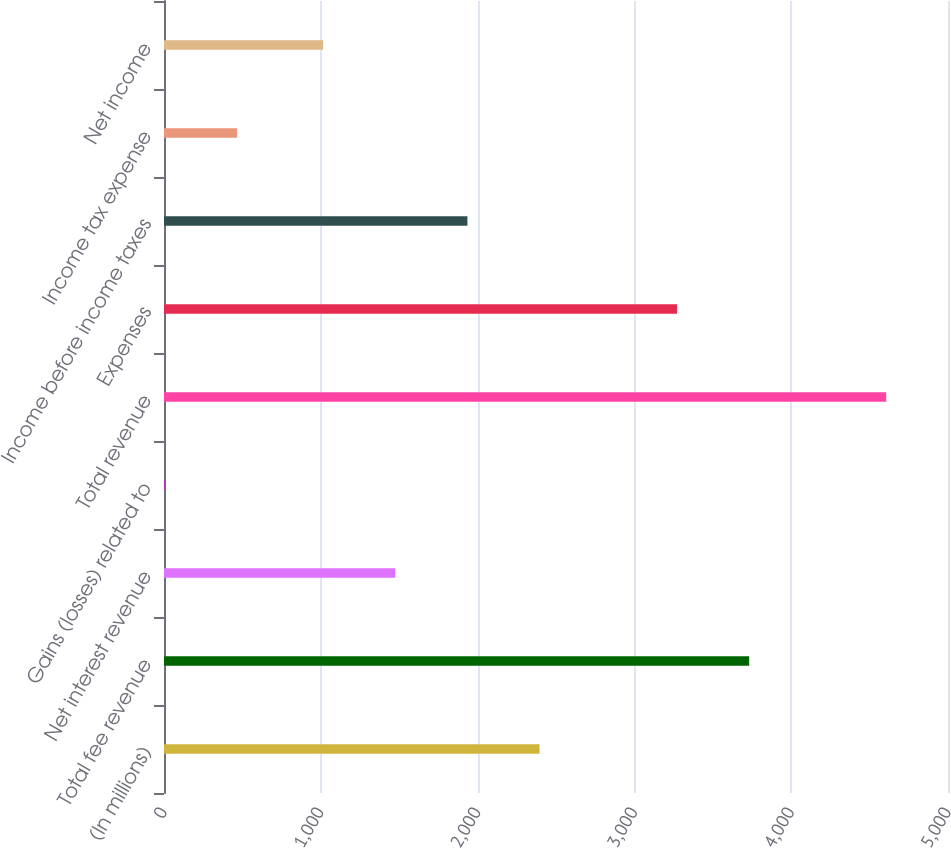Convert chart to OTSL. <chart><loc_0><loc_0><loc_500><loc_500><bar_chart><fcel>(In millions)<fcel>Total fee revenue<fcel>Net interest revenue<fcel>Gains (losses) related to<fcel>Total revenue<fcel>Expenses<fcel>Income before income taxes<fcel>Income tax expense<fcel>Net income<nl><fcel>2395<fcel>3732<fcel>1475<fcel>6<fcel>4606<fcel>3272<fcel>1935<fcel>466<fcel>1015<nl></chart> 